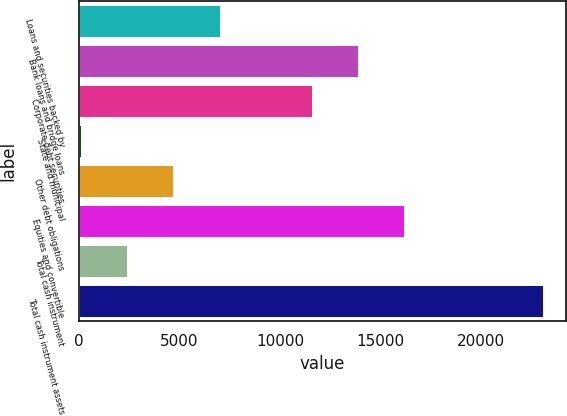Convert chart. <chart><loc_0><loc_0><loc_500><loc_500><bar_chart><fcel>Loans and securities backed by<fcel>Bank loans and bridge loans<fcel>Corporate debt securities<fcel>State and municipal<fcel>Other debt obligations<fcel>Equities and convertible<fcel>Total cash instrument<fcel>Total cash instrument assets<nl><fcel>6996.8<fcel>13883.6<fcel>11588<fcel>110<fcel>4701.2<fcel>16179.2<fcel>2405.6<fcel>23066<nl></chart> 